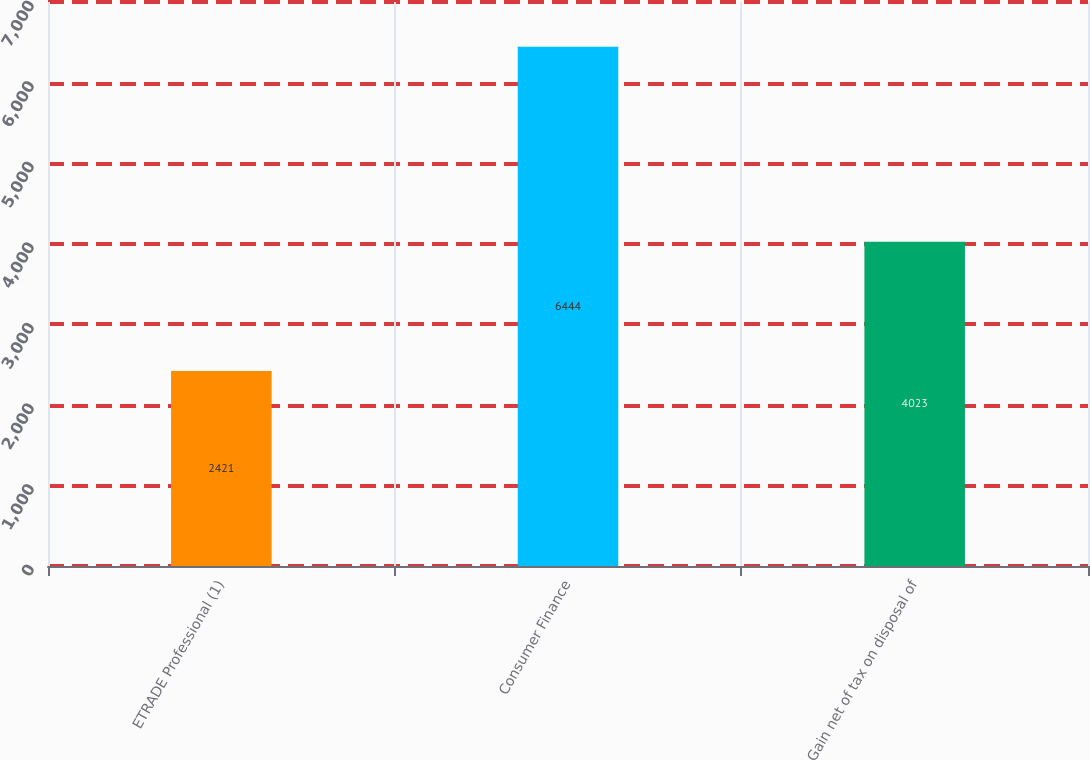Convert chart. <chart><loc_0><loc_0><loc_500><loc_500><bar_chart><fcel>ETRADE Professional (1)<fcel>Consumer Finance<fcel>Gain net of tax on disposal of<nl><fcel>2421<fcel>6444<fcel>4023<nl></chart> 